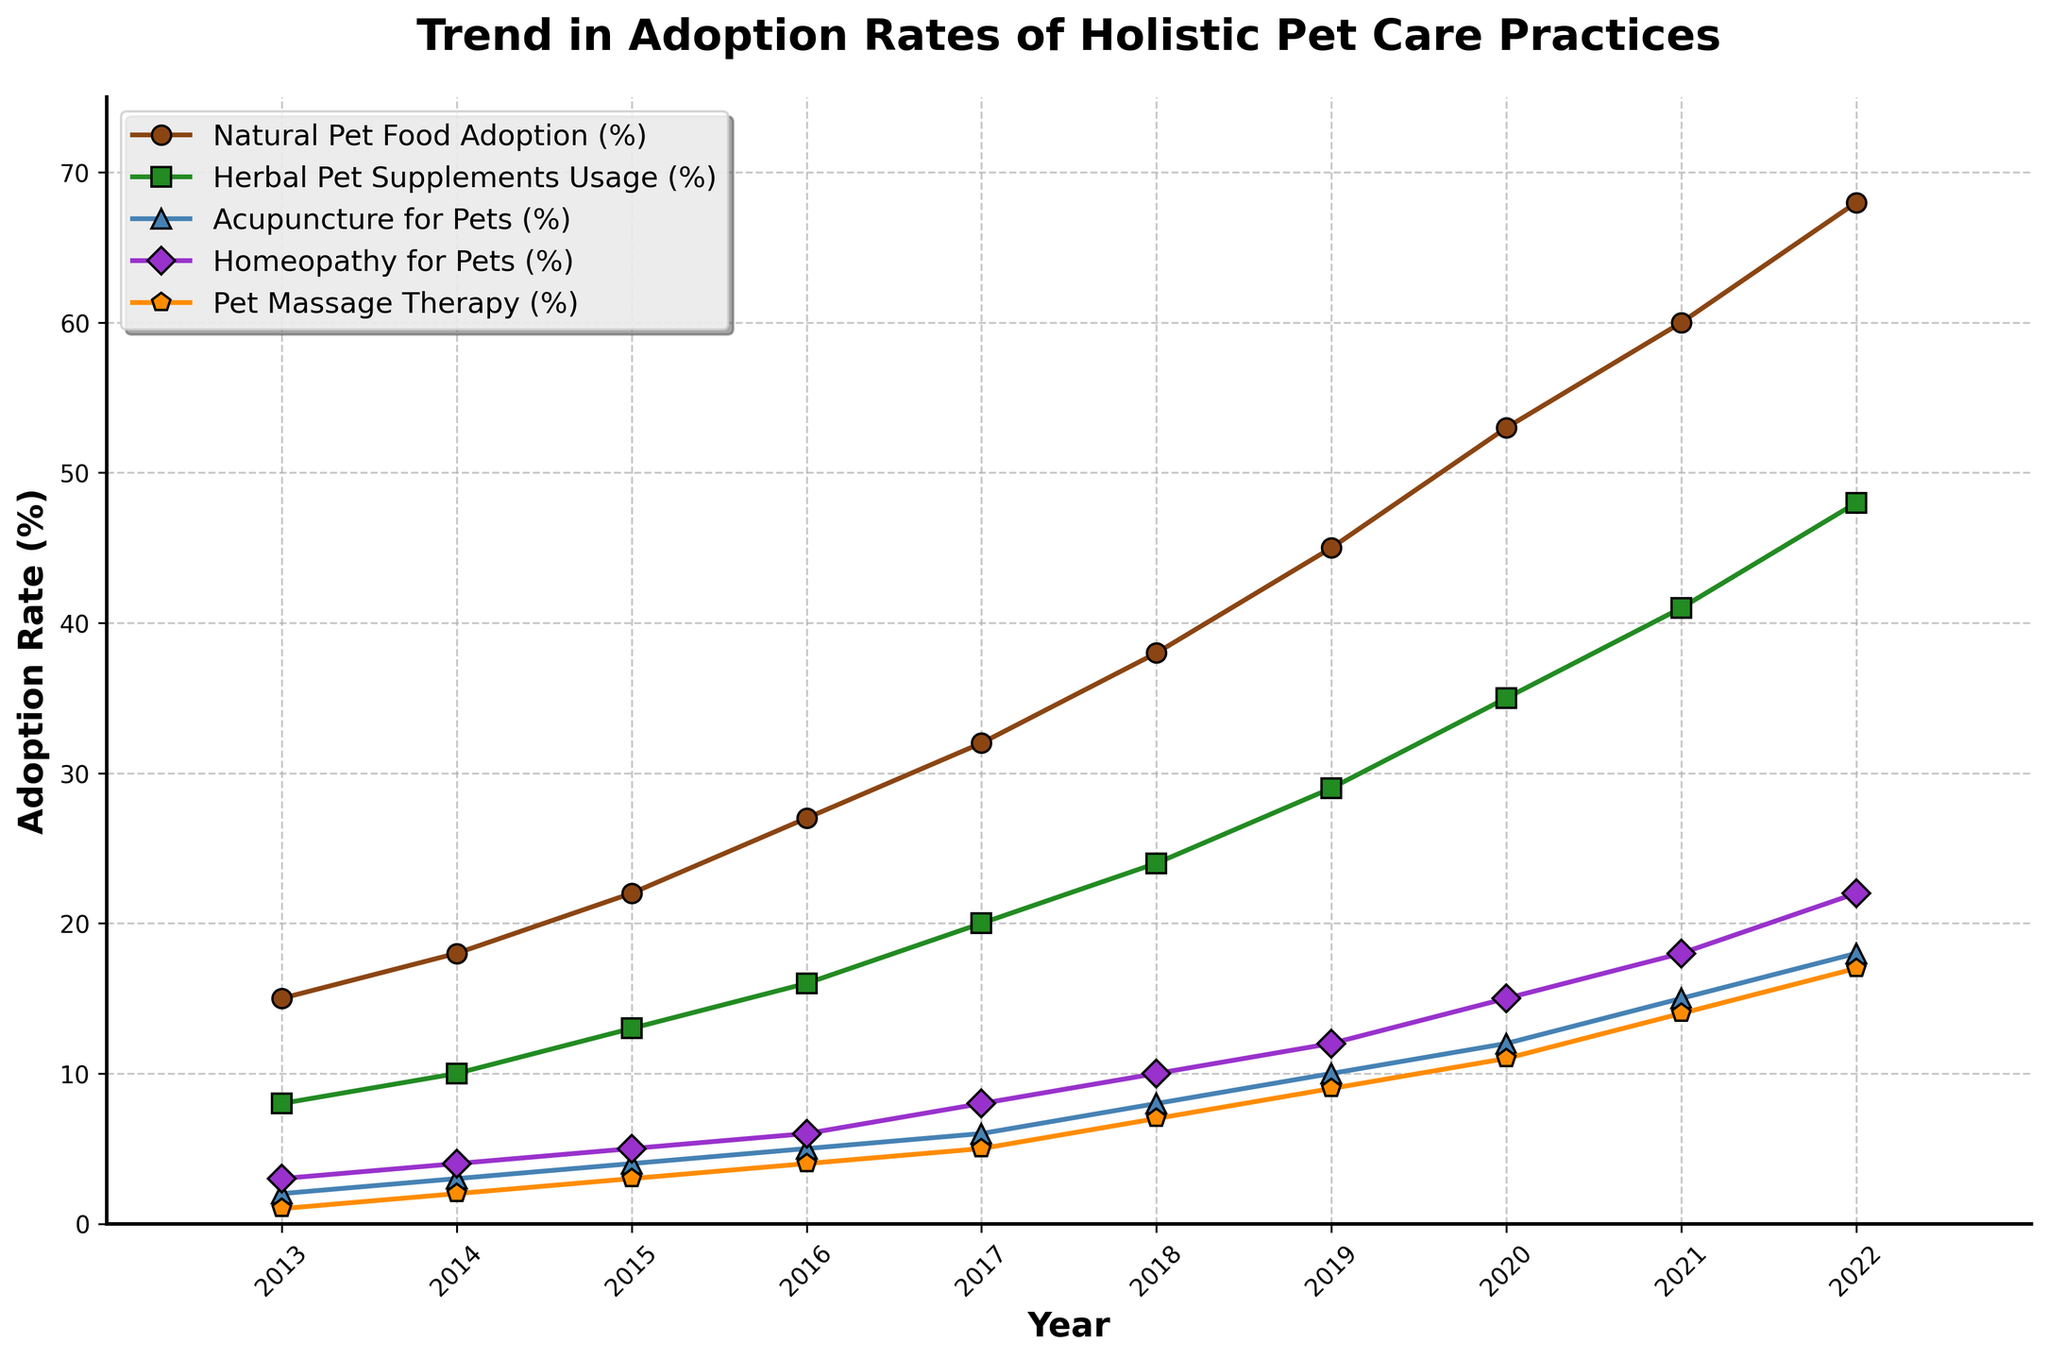What is the adoption rate of Natural Pet Food in 2020? Look for the data point corresponding to 2020 on the chart where the line for Natural Pet Food Adoption intersects the vertical line for 2020.
Answer: 53% Which holistic pet care practice showed the largest increase in adoption rates from 2013 to 2022? By comparing the starting and ending points for each practice, identify which practice had the highest percentage increase. Natural Pet Food Adoption increased from 15% to 68%, which is the largest increase.
Answer: Natural Pet Food Adoption How does the adoption rate of Homeopathy for Pets in 2018 compare to Herbal Pet Supplements Usage in 2014? Identify the two data points on the chart and compare their values. Homeopathy for Pets was at 10% in 2018, while Herbal Pet Supplements were at 10% in 2014. They are equal.
Answer: Equal By how much did the adoption rate of Pet Massage Therapy increase from 2016 to 2022? Locate the adoption rates for Pet Massage Therapy in 2016 and 2022. The rates are 4% in 2016 and 17% in 2022. Compute the difference: 17% - 4% = 13%.
Answer: 13% What is the average adoption rate of Acupuncture for Pets over the entire decade? Add the adoption rates of Acupuncture for Pets from 2013 to 2022 and divide by the number of data points (10 years): (2 + 3 + 4 + 5 + 6 + 8 + 10 + 12 + 15 + 18)/10 = 83/10 = 8.3%.
Answer: 8.3% Which practice had the lowest adoption rate in 2014 and what was it? Identify the practice with the lowest data point in 2014. Pet Massage Therapy had the lowest adoption rate of 2% in 2014.
Answer: Pet Massage Therapy, 2% Did Herbal Pet Supplements Usage surpass the 30% mark before 2020? Check the adoption rates for Herbal Pet Supplements Usage before 2020. In 2019, the adoption rate was 29%, and in 2020, it was 35%, so it did not surpass 30% before 2020.
Answer: No What was the trend (increasing or decreasing) in Natural Pet Food Adoption from 2013 to 2022? Observe the line for Natural Pet Food Adoption from 2013 to 2022. It shows a consistently increasing trend.
Answer: Increasing How many years did it take for Herbal Pet Supplements Usage to increase from 10% to 41%? Identify the years when Herbal Pet Supplements Usage was 10% and 41%. 10% was in 2014 and 41% was in 2021. Compute the difference: 2021 - 2014 = 7 years.
Answer: 7 years 